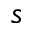<formula> <loc_0><loc_0><loc_500><loc_500>s</formula> 